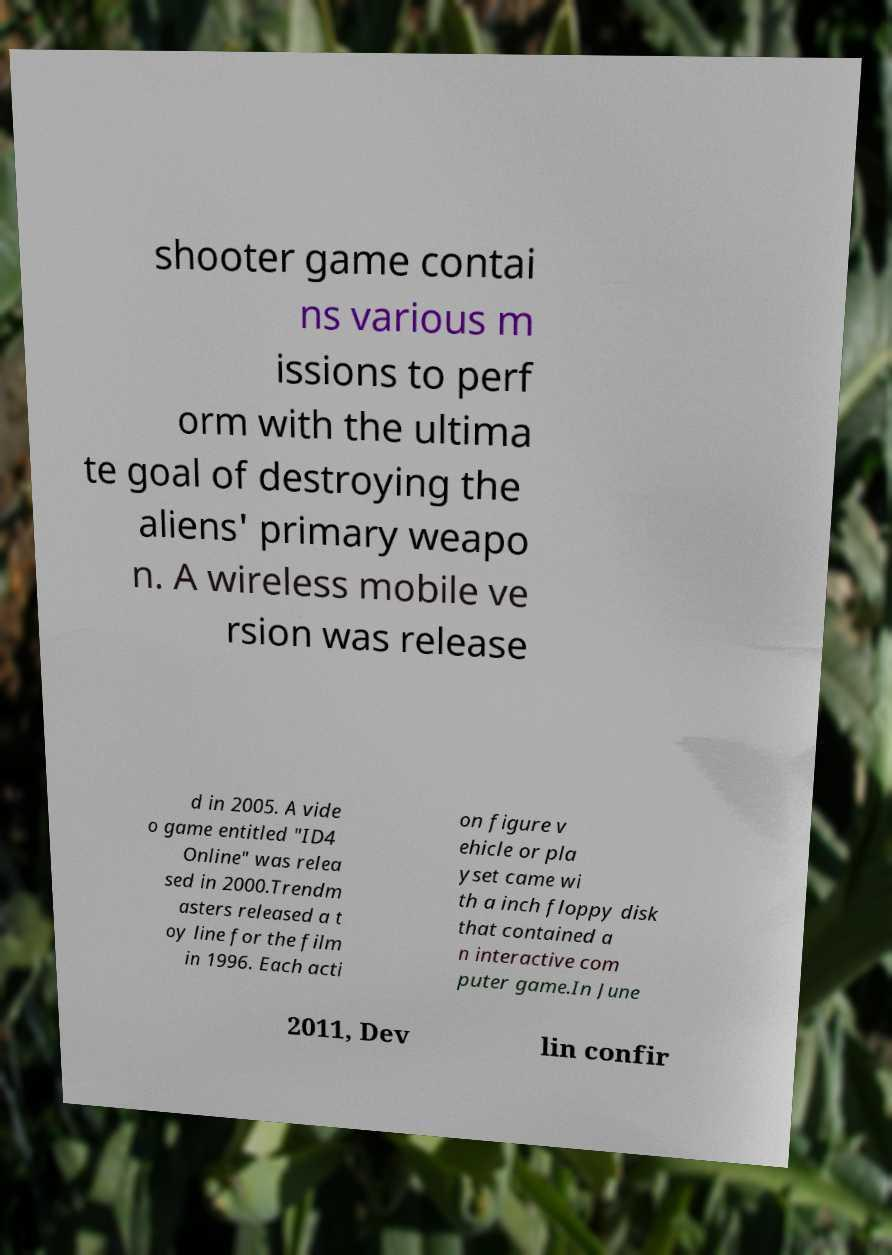For documentation purposes, I need the text within this image transcribed. Could you provide that? shooter game contai ns various m issions to perf orm with the ultima te goal of destroying the aliens' primary weapo n. A wireless mobile ve rsion was release d in 2005. A vide o game entitled "ID4 Online" was relea sed in 2000.Trendm asters released a t oy line for the film in 1996. Each acti on figure v ehicle or pla yset came wi th a inch floppy disk that contained a n interactive com puter game.In June 2011, Dev lin confir 